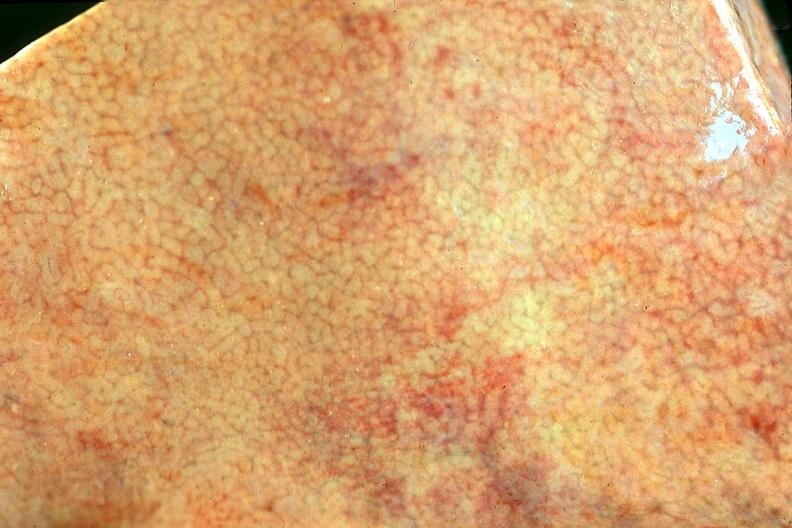what is present?
Answer the question using a single word or phrase. Hepatobiliary 